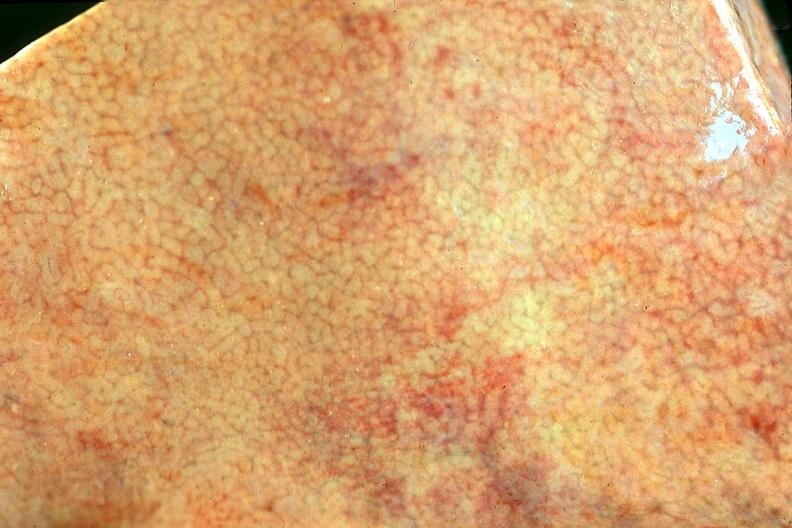what is present?
Answer the question using a single word or phrase. Hepatobiliary 